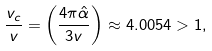Convert formula to latex. <formula><loc_0><loc_0><loc_500><loc_500>\frac { v _ { c } } { v } = \left ( \frac { 4 \pi { \hat { \alpha } } } { 3 v } \right ) \approx 4 . 0 0 5 4 > 1 ,</formula> 